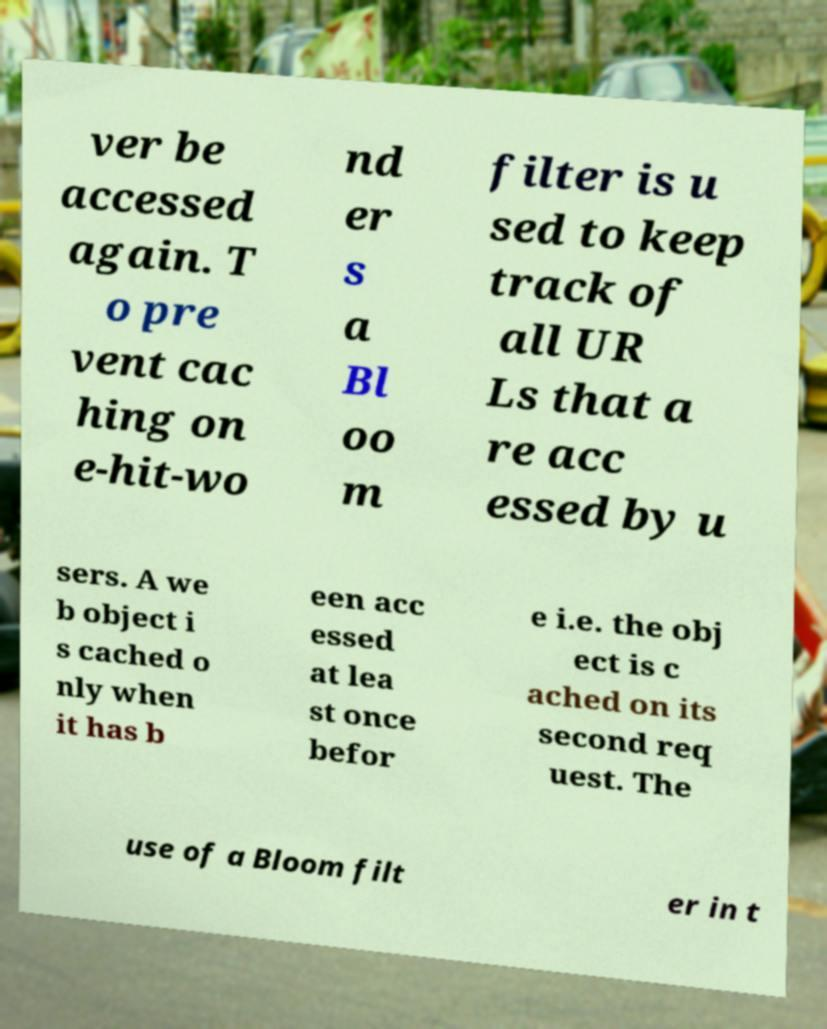Could you extract and type out the text from this image? ver be accessed again. T o pre vent cac hing on e-hit-wo nd er s a Bl oo m filter is u sed to keep track of all UR Ls that a re acc essed by u sers. A we b object i s cached o nly when it has b een acc essed at lea st once befor e i.e. the obj ect is c ached on its second req uest. The use of a Bloom filt er in t 